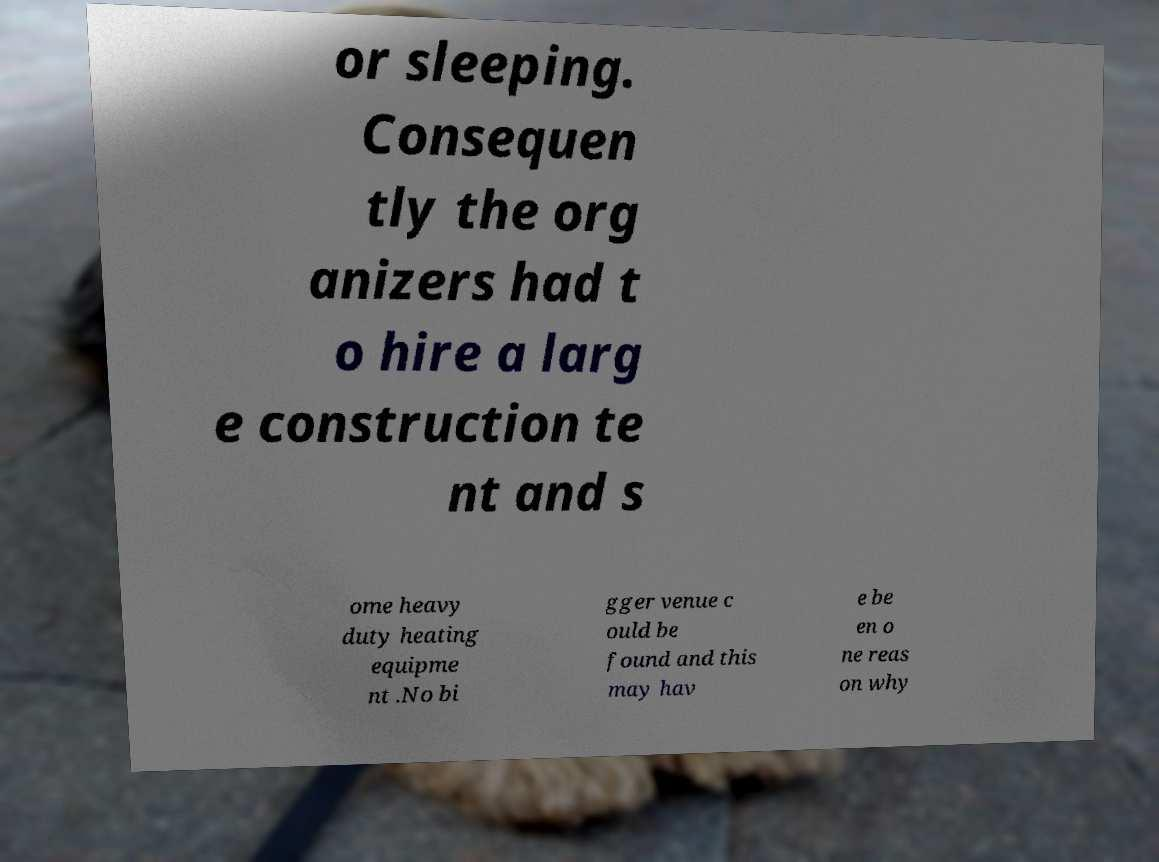There's text embedded in this image that I need extracted. Can you transcribe it verbatim? or sleeping. Consequen tly the org anizers had t o hire a larg e construction te nt and s ome heavy duty heating equipme nt .No bi gger venue c ould be found and this may hav e be en o ne reas on why 